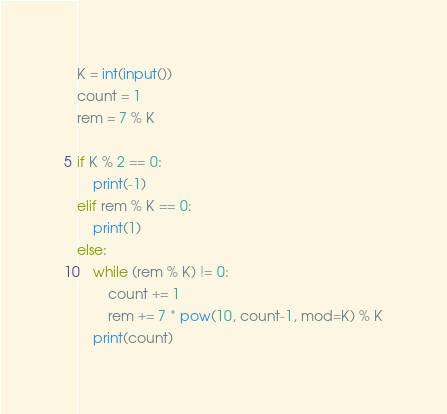<code> <loc_0><loc_0><loc_500><loc_500><_Python_>K = int(input())
count = 1
rem = 7 % K

if K % 2 == 0:
    print(-1)
elif rem % K == 0:
    print(1)
else:
    while (rem % K) != 0:
        count += 1
        rem += 7 * pow(10, count-1, mod=K) % K
    print(count)
</code> 